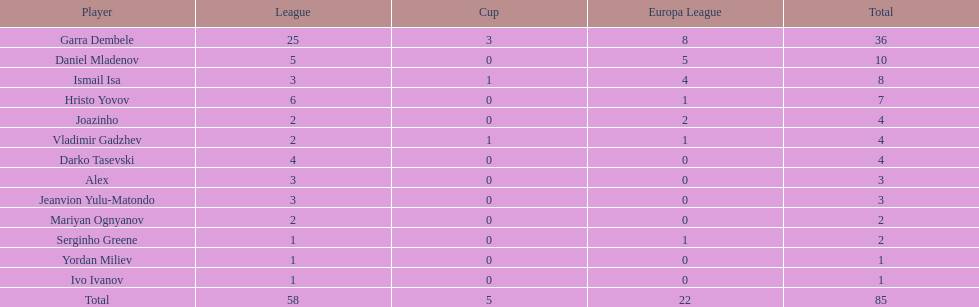Who scored the highest number of goals? Garra Dembele. 